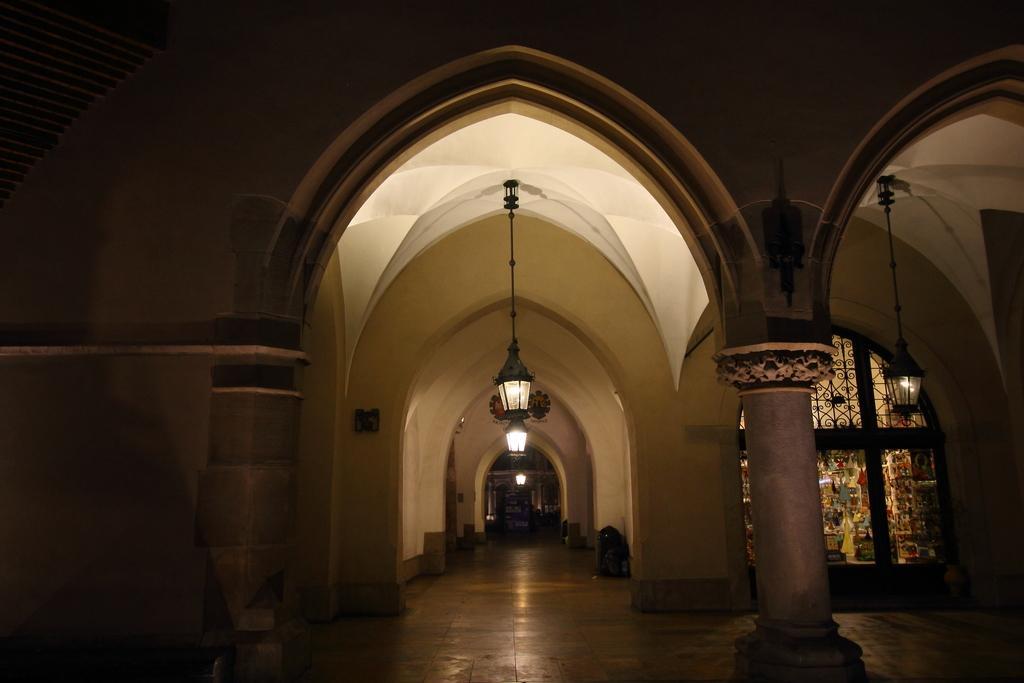Can you describe this image briefly? The picture is clicked inside a building. On the background there are arch like structure. From the roof lights are hanged. 